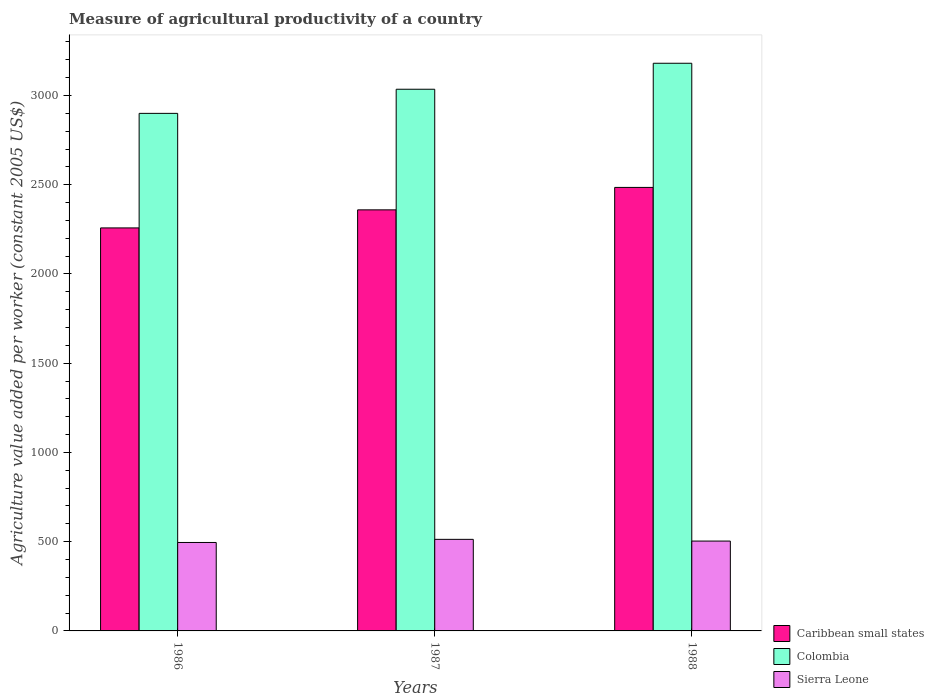How many bars are there on the 1st tick from the left?
Ensure brevity in your answer.  3. How many bars are there on the 1st tick from the right?
Provide a succinct answer. 3. What is the measure of agricultural productivity in Sierra Leone in 1988?
Make the answer very short. 503.46. Across all years, what is the maximum measure of agricultural productivity in Caribbean small states?
Keep it short and to the point. 2484.96. Across all years, what is the minimum measure of agricultural productivity in Caribbean small states?
Provide a short and direct response. 2258.01. In which year was the measure of agricultural productivity in Sierra Leone maximum?
Provide a short and direct response. 1987. In which year was the measure of agricultural productivity in Colombia minimum?
Ensure brevity in your answer.  1986. What is the total measure of agricultural productivity in Caribbean small states in the graph?
Your response must be concise. 7102.18. What is the difference between the measure of agricultural productivity in Caribbean small states in 1986 and that in 1988?
Provide a succinct answer. -226.94. What is the difference between the measure of agricultural productivity in Sierra Leone in 1986 and the measure of agricultural productivity in Colombia in 1988?
Provide a short and direct response. -2685.07. What is the average measure of agricultural productivity in Caribbean small states per year?
Keep it short and to the point. 2367.39. In the year 1987, what is the difference between the measure of agricultural productivity in Colombia and measure of agricultural productivity in Caribbean small states?
Offer a very short reply. 675.77. In how many years, is the measure of agricultural productivity in Sierra Leone greater than 2700 US$?
Offer a very short reply. 0. What is the ratio of the measure of agricultural productivity in Colombia in 1986 to that in 1988?
Your answer should be very brief. 0.91. What is the difference between the highest and the second highest measure of agricultural productivity in Caribbean small states?
Offer a very short reply. 125.75. What is the difference between the highest and the lowest measure of agricultural productivity in Colombia?
Make the answer very short. 280.79. In how many years, is the measure of agricultural productivity in Caribbean small states greater than the average measure of agricultural productivity in Caribbean small states taken over all years?
Offer a terse response. 1. What does the 2nd bar from the left in 1986 represents?
Your answer should be very brief. Colombia. Are all the bars in the graph horizontal?
Your answer should be compact. No. How many years are there in the graph?
Keep it short and to the point. 3. What is the difference between two consecutive major ticks on the Y-axis?
Provide a short and direct response. 500. Does the graph contain any zero values?
Provide a short and direct response. No. Does the graph contain grids?
Your answer should be very brief. No. How many legend labels are there?
Offer a terse response. 3. What is the title of the graph?
Provide a short and direct response. Measure of agricultural productivity of a country. Does "Micronesia" appear as one of the legend labels in the graph?
Ensure brevity in your answer.  No. What is the label or title of the X-axis?
Your response must be concise. Years. What is the label or title of the Y-axis?
Your response must be concise. Agriculture value added per worker (constant 2005 US$). What is the Agriculture value added per worker (constant 2005 US$) in Caribbean small states in 1986?
Provide a short and direct response. 2258.01. What is the Agriculture value added per worker (constant 2005 US$) in Colombia in 1986?
Your answer should be very brief. 2899.8. What is the Agriculture value added per worker (constant 2005 US$) in Sierra Leone in 1986?
Offer a very short reply. 495.52. What is the Agriculture value added per worker (constant 2005 US$) in Caribbean small states in 1987?
Give a very brief answer. 2359.21. What is the Agriculture value added per worker (constant 2005 US$) in Colombia in 1987?
Provide a short and direct response. 3034.98. What is the Agriculture value added per worker (constant 2005 US$) in Sierra Leone in 1987?
Give a very brief answer. 513.04. What is the Agriculture value added per worker (constant 2005 US$) of Caribbean small states in 1988?
Keep it short and to the point. 2484.96. What is the Agriculture value added per worker (constant 2005 US$) in Colombia in 1988?
Keep it short and to the point. 3180.59. What is the Agriculture value added per worker (constant 2005 US$) of Sierra Leone in 1988?
Make the answer very short. 503.46. Across all years, what is the maximum Agriculture value added per worker (constant 2005 US$) in Caribbean small states?
Provide a succinct answer. 2484.96. Across all years, what is the maximum Agriculture value added per worker (constant 2005 US$) of Colombia?
Provide a succinct answer. 3180.59. Across all years, what is the maximum Agriculture value added per worker (constant 2005 US$) of Sierra Leone?
Give a very brief answer. 513.04. Across all years, what is the minimum Agriculture value added per worker (constant 2005 US$) of Caribbean small states?
Offer a terse response. 2258.01. Across all years, what is the minimum Agriculture value added per worker (constant 2005 US$) in Colombia?
Your answer should be compact. 2899.8. Across all years, what is the minimum Agriculture value added per worker (constant 2005 US$) in Sierra Leone?
Offer a very short reply. 495.52. What is the total Agriculture value added per worker (constant 2005 US$) in Caribbean small states in the graph?
Keep it short and to the point. 7102.18. What is the total Agriculture value added per worker (constant 2005 US$) of Colombia in the graph?
Keep it short and to the point. 9115.37. What is the total Agriculture value added per worker (constant 2005 US$) of Sierra Leone in the graph?
Provide a succinct answer. 1512.02. What is the difference between the Agriculture value added per worker (constant 2005 US$) of Caribbean small states in 1986 and that in 1987?
Your response must be concise. -101.19. What is the difference between the Agriculture value added per worker (constant 2005 US$) in Colombia in 1986 and that in 1987?
Your response must be concise. -135.18. What is the difference between the Agriculture value added per worker (constant 2005 US$) in Sierra Leone in 1986 and that in 1987?
Make the answer very short. -17.52. What is the difference between the Agriculture value added per worker (constant 2005 US$) in Caribbean small states in 1986 and that in 1988?
Offer a terse response. -226.94. What is the difference between the Agriculture value added per worker (constant 2005 US$) in Colombia in 1986 and that in 1988?
Provide a succinct answer. -280.79. What is the difference between the Agriculture value added per worker (constant 2005 US$) in Sierra Leone in 1986 and that in 1988?
Give a very brief answer. -7.94. What is the difference between the Agriculture value added per worker (constant 2005 US$) of Caribbean small states in 1987 and that in 1988?
Your response must be concise. -125.75. What is the difference between the Agriculture value added per worker (constant 2005 US$) of Colombia in 1987 and that in 1988?
Offer a terse response. -145.61. What is the difference between the Agriculture value added per worker (constant 2005 US$) of Sierra Leone in 1987 and that in 1988?
Provide a succinct answer. 9.58. What is the difference between the Agriculture value added per worker (constant 2005 US$) in Caribbean small states in 1986 and the Agriculture value added per worker (constant 2005 US$) in Colombia in 1987?
Keep it short and to the point. -776.97. What is the difference between the Agriculture value added per worker (constant 2005 US$) in Caribbean small states in 1986 and the Agriculture value added per worker (constant 2005 US$) in Sierra Leone in 1987?
Provide a short and direct response. 1744.97. What is the difference between the Agriculture value added per worker (constant 2005 US$) of Colombia in 1986 and the Agriculture value added per worker (constant 2005 US$) of Sierra Leone in 1987?
Offer a terse response. 2386.76. What is the difference between the Agriculture value added per worker (constant 2005 US$) of Caribbean small states in 1986 and the Agriculture value added per worker (constant 2005 US$) of Colombia in 1988?
Offer a terse response. -922.57. What is the difference between the Agriculture value added per worker (constant 2005 US$) in Caribbean small states in 1986 and the Agriculture value added per worker (constant 2005 US$) in Sierra Leone in 1988?
Ensure brevity in your answer.  1754.56. What is the difference between the Agriculture value added per worker (constant 2005 US$) in Colombia in 1986 and the Agriculture value added per worker (constant 2005 US$) in Sierra Leone in 1988?
Make the answer very short. 2396.34. What is the difference between the Agriculture value added per worker (constant 2005 US$) in Caribbean small states in 1987 and the Agriculture value added per worker (constant 2005 US$) in Colombia in 1988?
Offer a very short reply. -821.38. What is the difference between the Agriculture value added per worker (constant 2005 US$) in Caribbean small states in 1987 and the Agriculture value added per worker (constant 2005 US$) in Sierra Leone in 1988?
Your response must be concise. 1855.75. What is the difference between the Agriculture value added per worker (constant 2005 US$) in Colombia in 1987 and the Agriculture value added per worker (constant 2005 US$) in Sierra Leone in 1988?
Offer a terse response. 2531.52. What is the average Agriculture value added per worker (constant 2005 US$) of Caribbean small states per year?
Offer a very short reply. 2367.39. What is the average Agriculture value added per worker (constant 2005 US$) in Colombia per year?
Ensure brevity in your answer.  3038.46. What is the average Agriculture value added per worker (constant 2005 US$) in Sierra Leone per year?
Offer a very short reply. 504.01. In the year 1986, what is the difference between the Agriculture value added per worker (constant 2005 US$) in Caribbean small states and Agriculture value added per worker (constant 2005 US$) in Colombia?
Provide a succinct answer. -641.79. In the year 1986, what is the difference between the Agriculture value added per worker (constant 2005 US$) in Caribbean small states and Agriculture value added per worker (constant 2005 US$) in Sierra Leone?
Ensure brevity in your answer.  1762.49. In the year 1986, what is the difference between the Agriculture value added per worker (constant 2005 US$) in Colombia and Agriculture value added per worker (constant 2005 US$) in Sierra Leone?
Your answer should be very brief. 2404.28. In the year 1987, what is the difference between the Agriculture value added per worker (constant 2005 US$) in Caribbean small states and Agriculture value added per worker (constant 2005 US$) in Colombia?
Keep it short and to the point. -675.77. In the year 1987, what is the difference between the Agriculture value added per worker (constant 2005 US$) of Caribbean small states and Agriculture value added per worker (constant 2005 US$) of Sierra Leone?
Provide a short and direct response. 1846.17. In the year 1987, what is the difference between the Agriculture value added per worker (constant 2005 US$) of Colombia and Agriculture value added per worker (constant 2005 US$) of Sierra Leone?
Give a very brief answer. 2521.94. In the year 1988, what is the difference between the Agriculture value added per worker (constant 2005 US$) of Caribbean small states and Agriculture value added per worker (constant 2005 US$) of Colombia?
Offer a very short reply. -695.63. In the year 1988, what is the difference between the Agriculture value added per worker (constant 2005 US$) of Caribbean small states and Agriculture value added per worker (constant 2005 US$) of Sierra Leone?
Your answer should be compact. 1981.5. In the year 1988, what is the difference between the Agriculture value added per worker (constant 2005 US$) of Colombia and Agriculture value added per worker (constant 2005 US$) of Sierra Leone?
Make the answer very short. 2677.13. What is the ratio of the Agriculture value added per worker (constant 2005 US$) of Caribbean small states in 1986 to that in 1987?
Your response must be concise. 0.96. What is the ratio of the Agriculture value added per worker (constant 2005 US$) in Colombia in 1986 to that in 1987?
Provide a succinct answer. 0.96. What is the ratio of the Agriculture value added per worker (constant 2005 US$) in Sierra Leone in 1986 to that in 1987?
Give a very brief answer. 0.97. What is the ratio of the Agriculture value added per worker (constant 2005 US$) in Caribbean small states in 1986 to that in 1988?
Make the answer very short. 0.91. What is the ratio of the Agriculture value added per worker (constant 2005 US$) in Colombia in 1986 to that in 1988?
Your response must be concise. 0.91. What is the ratio of the Agriculture value added per worker (constant 2005 US$) in Sierra Leone in 1986 to that in 1988?
Provide a short and direct response. 0.98. What is the ratio of the Agriculture value added per worker (constant 2005 US$) in Caribbean small states in 1987 to that in 1988?
Your response must be concise. 0.95. What is the ratio of the Agriculture value added per worker (constant 2005 US$) of Colombia in 1987 to that in 1988?
Make the answer very short. 0.95. What is the difference between the highest and the second highest Agriculture value added per worker (constant 2005 US$) of Caribbean small states?
Make the answer very short. 125.75. What is the difference between the highest and the second highest Agriculture value added per worker (constant 2005 US$) in Colombia?
Provide a succinct answer. 145.61. What is the difference between the highest and the second highest Agriculture value added per worker (constant 2005 US$) in Sierra Leone?
Your response must be concise. 9.58. What is the difference between the highest and the lowest Agriculture value added per worker (constant 2005 US$) in Caribbean small states?
Make the answer very short. 226.94. What is the difference between the highest and the lowest Agriculture value added per worker (constant 2005 US$) in Colombia?
Your answer should be very brief. 280.79. What is the difference between the highest and the lowest Agriculture value added per worker (constant 2005 US$) in Sierra Leone?
Keep it short and to the point. 17.52. 